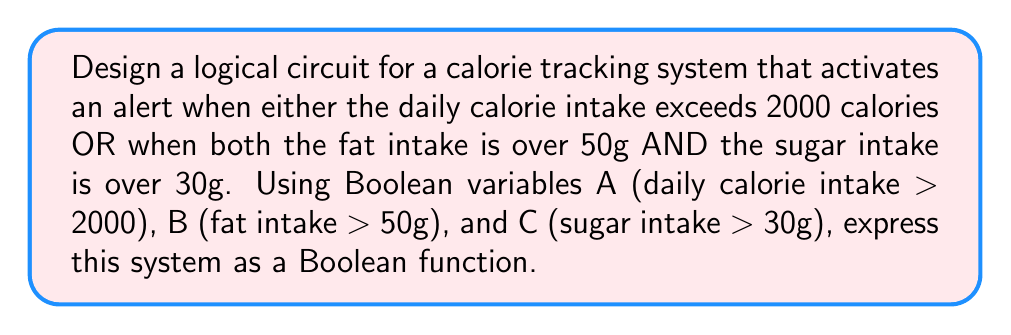Can you solve this math problem? Let's approach this step-by-step:

1) We need to activate the alert in two scenarios:
   a) When daily calorie intake exceeds 2000 calories (A is true)
   b) When both fat intake is over 50g AND sugar intake is over 30g (B AND C are true)

2) We can express this in Boolean algebra as:
   $$ F = A + (B \cdot C) $$

   Where:
   - $F$ is the final output (alert activation)
   - $A$ represents (daily calorie intake > 2000)
   - $B$ represents (fat intake > 50g)
   - $C$ represents (sugar intake > 30g)
   - $+$ represents the OR operation
   - $\cdot$ represents the AND operation

3) This can be represented as a logical circuit:

   [asy]
   import geometry;

   // Define points
   pair A = (0,80), B = (0,40), C = (0,0);
   pair andGate = (60,20), orGate = (120,50);
   pair output = (180,50);

   // Draw input lines
   draw(A--andGate,arrow=Arrow(TeXHead));
   draw(B--andGate,arrow=Arrow(TeXHead));
   draw(C--(60,60)--(60,80)--(100,80)--(100,60)--orGate,arrow=Arrow(TeXHead));

   // Draw gates
   filldraw(circle(andGate,20),fillpen=white);
   filldraw(circle(orGate,20),fillpen=white);
   label("AND", andGate);
   label("OR", orGate);

   // Draw output line
   draw(orGate--output,arrow=Arrow(TeXHead));

   // Labels
   label("A", A, W);
   label("B", B, W);
   label("C", C, W);
   label("F", output, E);
   [/asy]

4) This circuit will output true (activate the alert) when either A is true, or both B and C are true, which matches our requirements for the calorie tracking system.
Answer: $$ F = A + (B \cdot C) $$ 